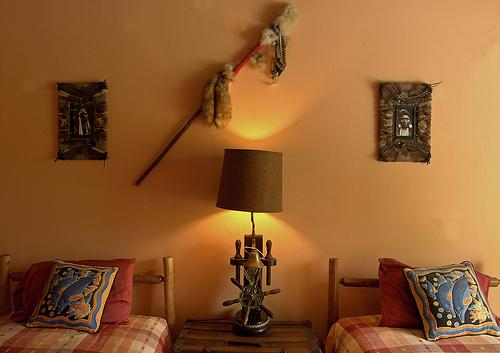Question: what room is this?
Choices:
A. Kitchen.
B. Den.
C. Basement.
D. Bedroom.
Answer with the letter. Answer: D Question: where is the lamp?
Choices:
A. Beside the bed.
B. On the end table.
C. The bookshelf.
D. On the nightstand.
Answer with the letter. Answer: D Question: how many beds?
Choices:
A. Three.
B. Two.
C. One.
D. Zero.
Answer with the letter. Answer: B Question: what is on the top pillows?
Choices:
A. Cats.
B. A persons head.
C. Flowers.
D. Seashells.
Answer with the letter. Answer: D Question: where are the pillows?
Choices:
A. On the floor.
B. On the beds.
C. On the couch.
D. On the chair.
Answer with the letter. Answer: B Question: how many total pillows?
Choices:
A. 1.
B. 2.
C. 3.
D. 4.
Answer with the letter. Answer: D Question: what style are the bedspreads?
Choices:
A. Plain.
B. Cream-colored.
C. Plaid.
D. Tie-dye.
Answer with the letter. Answer: C 